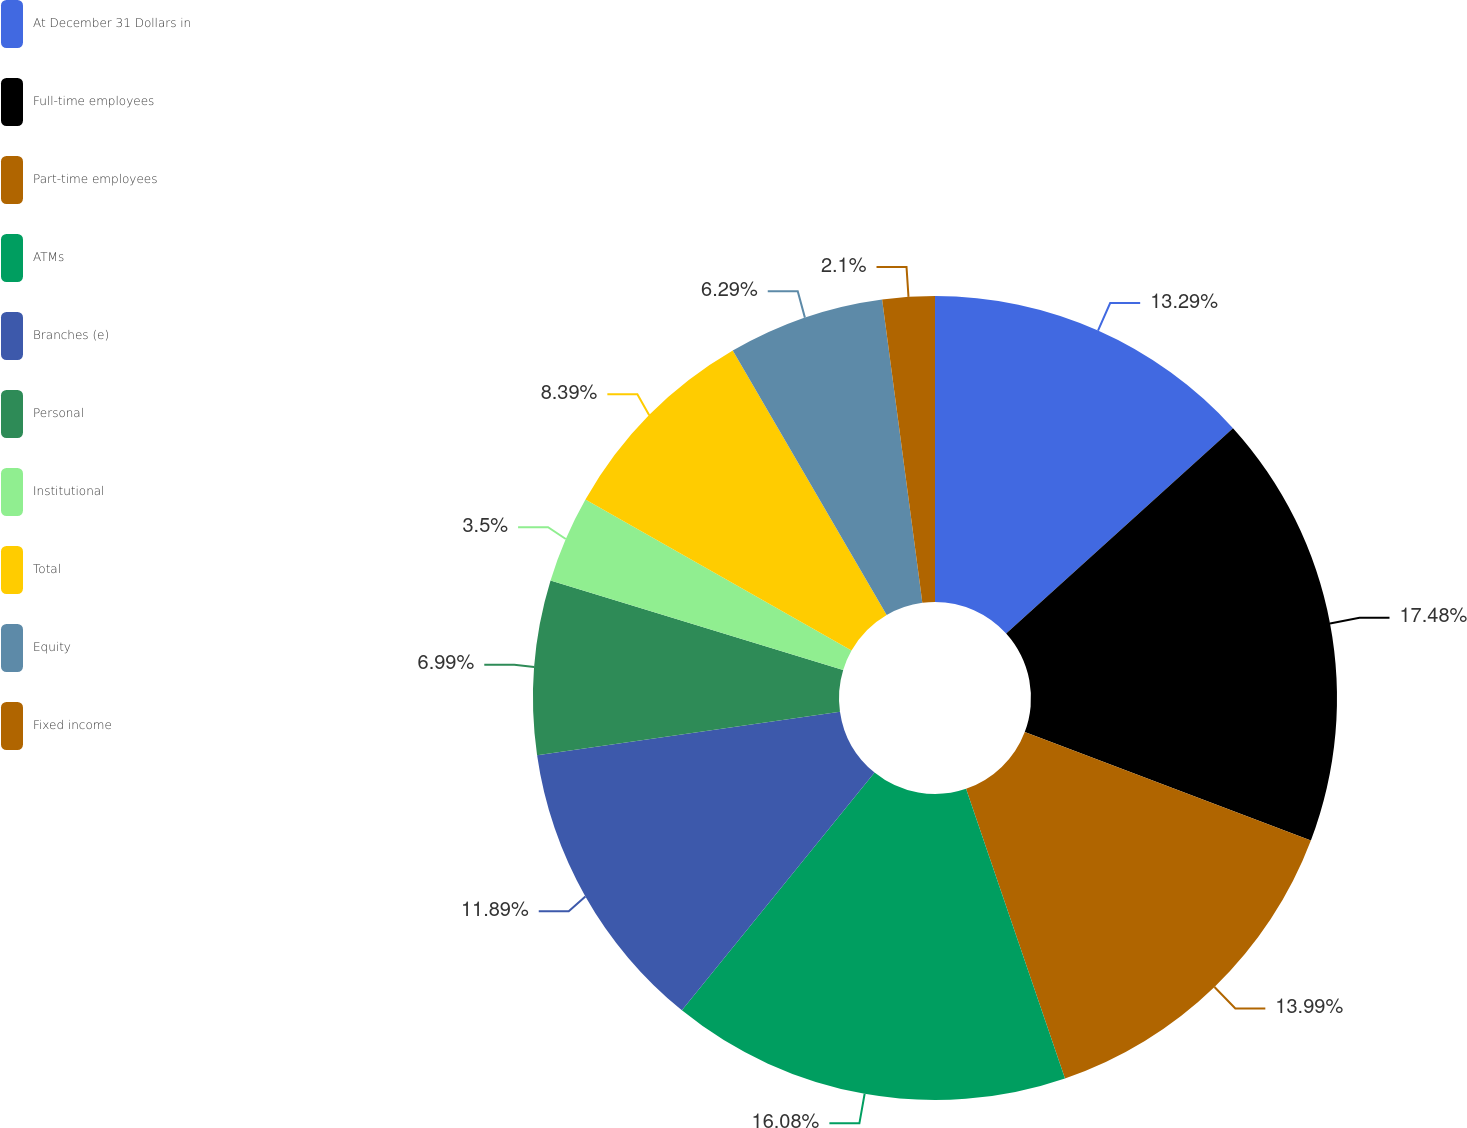<chart> <loc_0><loc_0><loc_500><loc_500><pie_chart><fcel>At December 31 Dollars in<fcel>Full-time employees<fcel>Part-time employees<fcel>ATMs<fcel>Branches (e)<fcel>Personal<fcel>Institutional<fcel>Total<fcel>Equity<fcel>Fixed income<nl><fcel>13.29%<fcel>17.48%<fcel>13.99%<fcel>16.08%<fcel>11.89%<fcel>6.99%<fcel>3.5%<fcel>8.39%<fcel>6.29%<fcel>2.1%<nl></chart> 